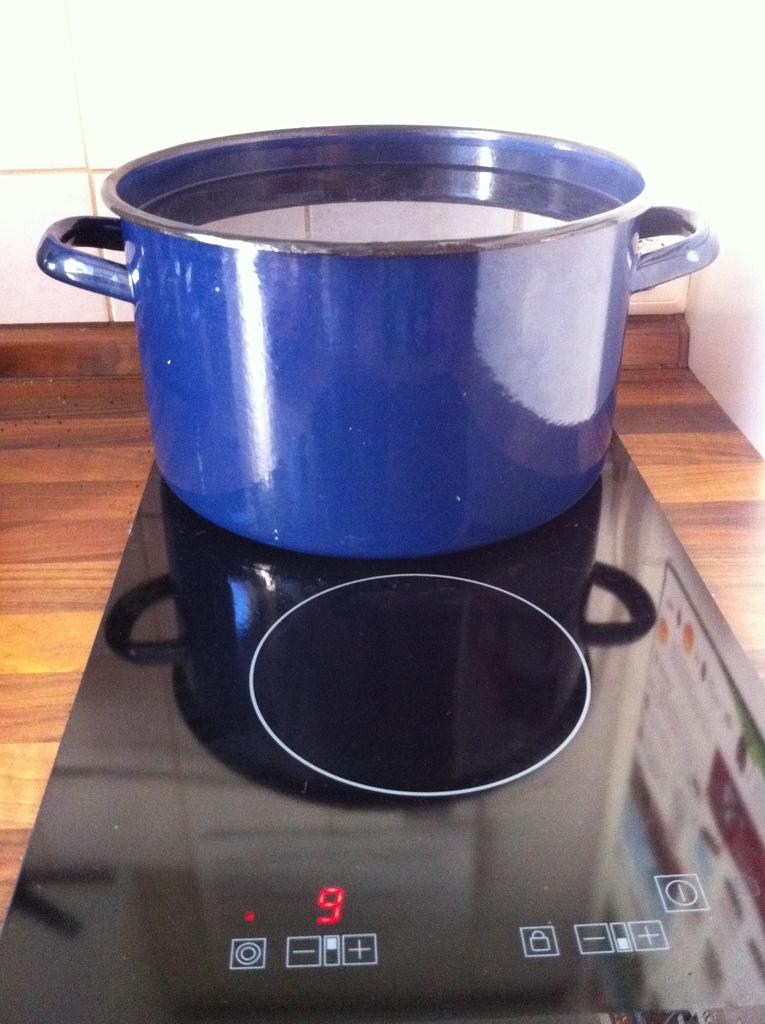<image>
Present a compact description of the photo's key features. A two burner portable stove with a blue stock pot on one of the burners with the digital number 9 showing on the stove. 